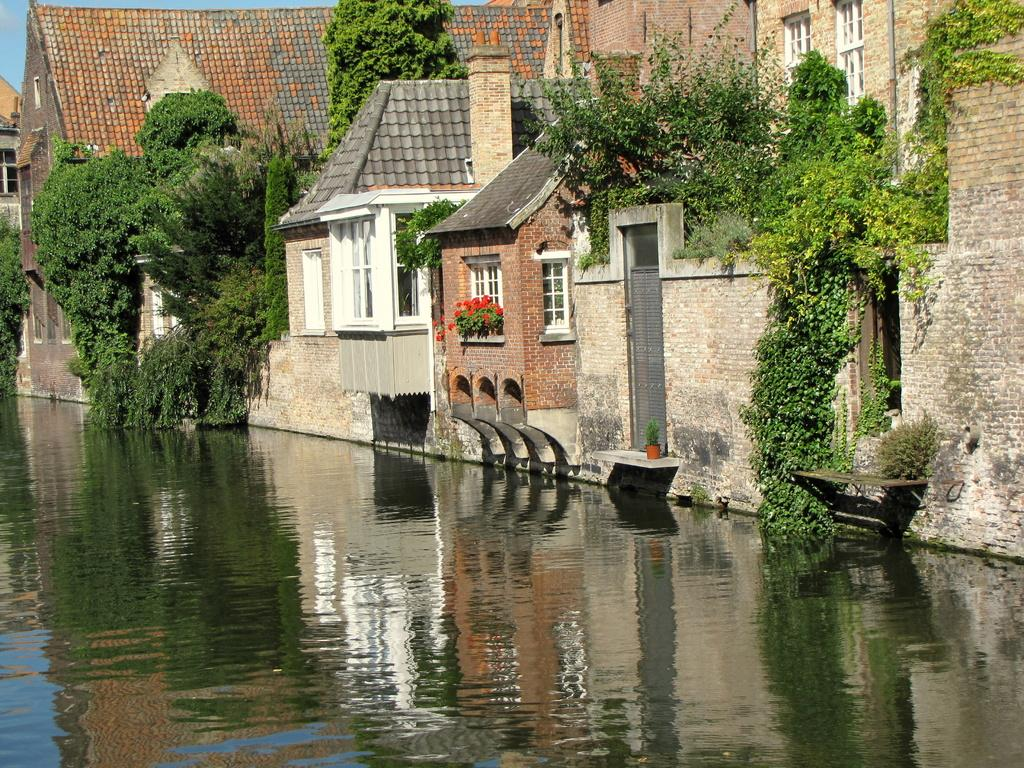What structure is the main subject of the image? There is a building in the image. What feature can be seen on the building? The building has windows. What activity is taking place near the building? There are climbers on the building. What natural feature is located beside the building? There is a lake beside the building. What type of bead is being sold at the market in the image? There is no market or bead present in the image; it features a building with climbers and a lake beside it. What impulse might the climbers have experienced to climb the building in the image? The image does not provide information about the climbers' motivations or impulses. 